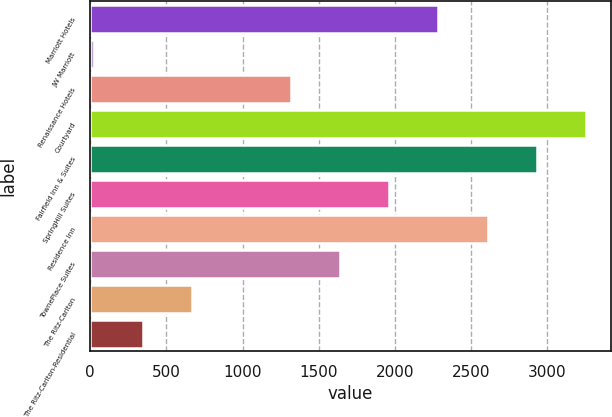Convert chart to OTSL. <chart><loc_0><loc_0><loc_500><loc_500><bar_chart><fcel>Marriott Hotels<fcel>JW Marriott<fcel>Renaissance Hotels<fcel>Courtyard<fcel>Fairfield Inn & Suites<fcel>SpringHill Suites<fcel>Residence Inn<fcel>TownePlace Suites<fcel>The Ritz-Carlton<fcel>The Ritz-Carlton-Residential<nl><fcel>2285.1<fcel>22<fcel>1315.2<fcel>3255<fcel>2931.7<fcel>1961.8<fcel>2608.4<fcel>1638.5<fcel>668.6<fcel>345.3<nl></chart> 